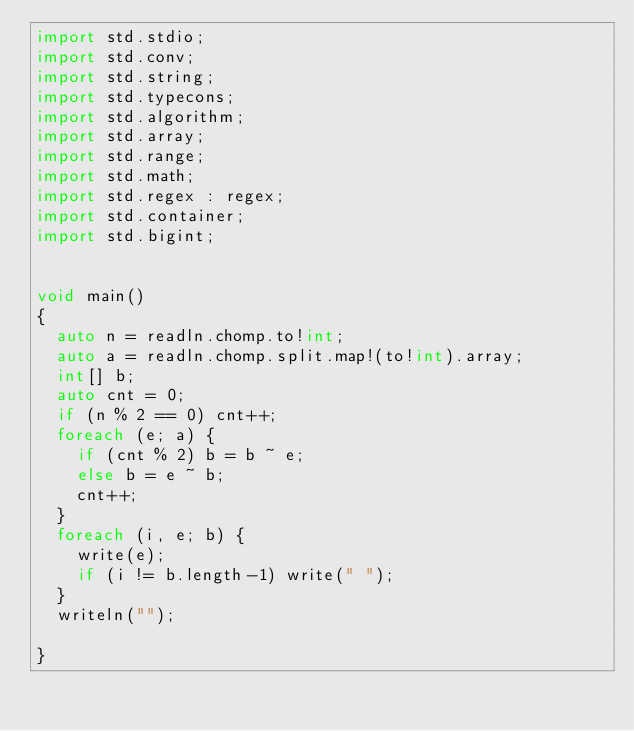Convert code to text. <code><loc_0><loc_0><loc_500><loc_500><_D_>import std.stdio;
import std.conv;
import std.string;
import std.typecons;
import std.algorithm;
import std.array;
import std.range;
import std.math;
import std.regex : regex;
import std.container;
import std.bigint;


void main()
{
  auto n = readln.chomp.to!int;
  auto a = readln.chomp.split.map!(to!int).array;
  int[] b;
  auto cnt = 0;
  if (n % 2 == 0) cnt++;
  foreach (e; a) {
    if (cnt % 2) b = b ~ e;
    else b = e ~ b;
    cnt++;
  }
  foreach (i, e; b) {
    write(e);
    if (i != b.length-1) write(" ");
  }
  writeln("");

}
</code> 